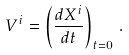<formula> <loc_0><loc_0><loc_500><loc_500>V ^ { i } = \left ( \frac { d X ^ { i } } { d t } \right ) _ { t = 0 } \, .</formula> 